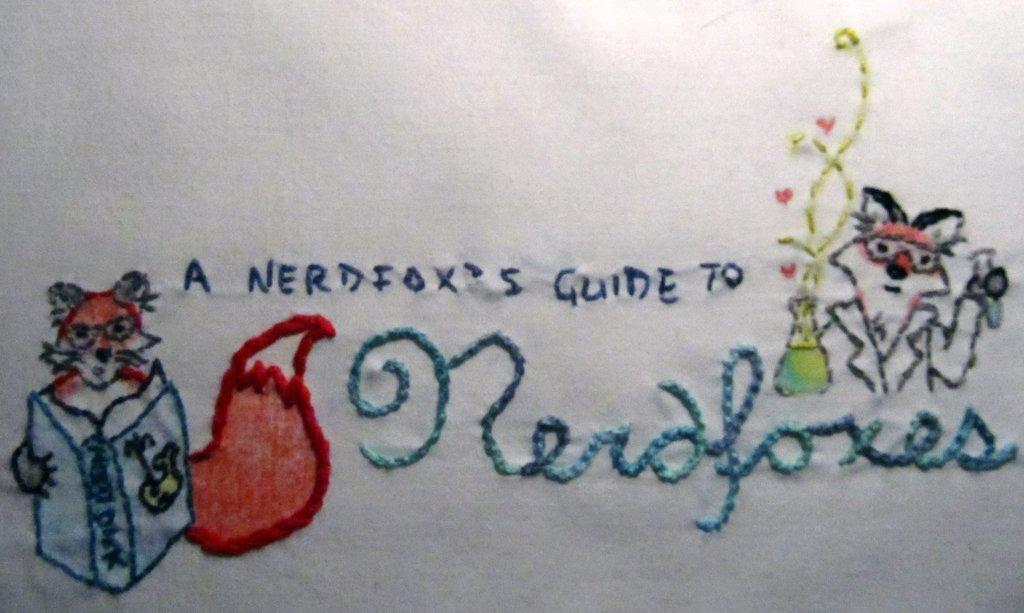What type of decoration is present on the cloth in the image? There is embroidery on the cloth. What elements are included in the embroidery? The embroidery includes text and images of animals. Can you see any snakes in the embroidery on the cloth? There are no snakes present in the embroidery on the cloth; it only includes text and images of animals. Is there any waste visible in the image? There is no waste present in the image; it only features the embroidered cloth. 